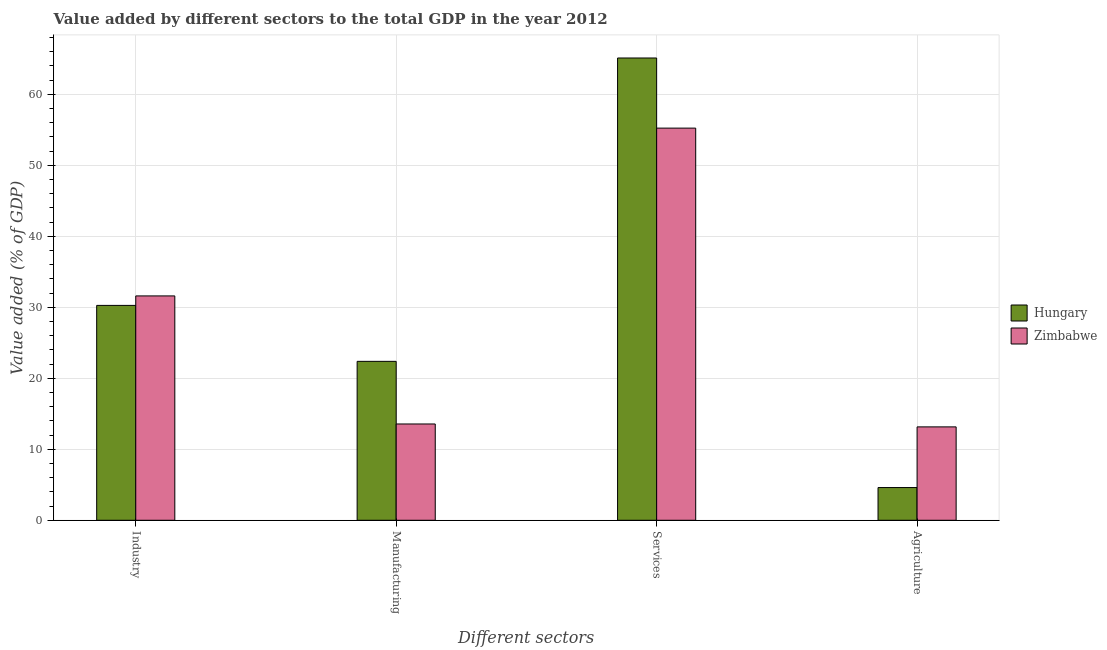How many different coloured bars are there?
Ensure brevity in your answer.  2. How many groups of bars are there?
Keep it short and to the point. 4. Are the number of bars on each tick of the X-axis equal?
Provide a short and direct response. Yes. How many bars are there on the 3rd tick from the right?
Your answer should be very brief. 2. What is the label of the 1st group of bars from the left?
Keep it short and to the point. Industry. What is the value added by services sector in Zimbabwe?
Offer a very short reply. 55.24. Across all countries, what is the maximum value added by manufacturing sector?
Provide a short and direct response. 22.39. Across all countries, what is the minimum value added by industrial sector?
Offer a terse response. 30.27. In which country was the value added by agricultural sector maximum?
Keep it short and to the point. Zimbabwe. In which country was the value added by industrial sector minimum?
Your answer should be very brief. Hungary. What is the total value added by industrial sector in the graph?
Your response must be concise. 61.87. What is the difference between the value added by industrial sector in Zimbabwe and that in Hungary?
Offer a very short reply. 1.33. What is the difference between the value added by agricultural sector in Hungary and the value added by manufacturing sector in Zimbabwe?
Provide a short and direct response. -8.96. What is the average value added by agricultural sector per country?
Provide a succinct answer. 8.88. What is the difference between the value added by agricultural sector and value added by services sector in Zimbabwe?
Keep it short and to the point. -42.09. What is the ratio of the value added by services sector in Hungary to that in Zimbabwe?
Make the answer very short. 1.18. Is the difference between the value added by services sector in Hungary and Zimbabwe greater than the difference between the value added by manufacturing sector in Hungary and Zimbabwe?
Ensure brevity in your answer.  Yes. What is the difference between the highest and the second highest value added by agricultural sector?
Make the answer very short. 8.55. What is the difference between the highest and the lowest value added by manufacturing sector?
Your answer should be very brief. 8.82. Is it the case that in every country, the sum of the value added by agricultural sector and value added by manufacturing sector is greater than the sum of value added by industrial sector and value added by services sector?
Offer a very short reply. No. What does the 2nd bar from the left in Industry represents?
Offer a very short reply. Zimbabwe. What does the 1st bar from the right in Industry represents?
Make the answer very short. Zimbabwe. Is it the case that in every country, the sum of the value added by industrial sector and value added by manufacturing sector is greater than the value added by services sector?
Ensure brevity in your answer.  No. How many bars are there?
Your answer should be compact. 8. Where does the legend appear in the graph?
Provide a succinct answer. Center right. What is the title of the graph?
Your answer should be compact. Value added by different sectors to the total GDP in the year 2012. What is the label or title of the X-axis?
Your answer should be very brief. Different sectors. What is the label or title of the Y-axis?
Make the answer very short. Value added (% of GDP). What is the Value added (% of GDP) in Hungary in Industry?
Make the answer very short. 30.27. What is the Value added (% of GDP) of Zimbabwe in Industry?
Ensure brevity in your answer.  31.6. What is the Value added (% of GDP) in Hungary in Manufacturing?
Offer a very short reply. 22.39. What is the Value added (% of GDP) of Zimbabwe in Manufacturing?
Provide a succinct answer. 13.57. What is the Value added (% of GDP) in Hungary in Services?
Keep it short and to the point. 65.12. What is the Value added (% of GDP) in Zimbabwe in Services?
Provide a succinct answer. 55.24. What is the Value added (% of GDP) in Hungary in Agriculture?
Your answer should be compact. 4.61. What is the Value added (% of GDP) of Zimbabwe in Agriculture?
Keep it short and to the point. 13.15. Across all Different sectors, what is the maximum Value added (% of GDP) of Hungary?
Ensure brevity in your answer.  65.12. Across all Different sectors, what is the maximum Value added (% of GDP) of Zimbabwe?
Ensure brevity in your answer.  55.24. Across all Different sectors, what is the minimum Value added (% of GDP) in Hungary?
Ensure brevity in your answer.  4.61. Across all Different sectors, what is the minimum Value added (% of GDP) of Zimbabwe?
Provide a succinct answer. 13.15. What is the total Value added (% of GDP) of Hungary in the graph?
Keep it short and to the point. 122.39. What is the total Value added (% of GDP) of Zimbabwe in the graph?
Make the answer very short. 113.57. What is the difference between the Value added (% of GDP) in Hungary in Industry and that in Manufacturing?
Your response must be concise. 7.88. What is the difference between the Value added (% of GDP) of Zimbabwe in Industry and that in Manufacturing?
Offer a terse response. 18.04. What is the difference between the Value added (% of GDP) in Hungary in Industry and that in Services?
Your answer should be very brief. -34.85. What is the difference between the Value added (% of GDP) of Zimbabwe in Industry and that in Services?
Provide a short and direct response. -23.64. What is the difference between the Value added (% of GDP) in Hungary in Industry and that in Agriculture?
Offer a terse response. 25.66. What is the difference between the Value added (% of GDP) of Zimbabwe in Industry and that in Agriculture?
Your response must be concise. 18.45. What is the difference between the Value added (% of GDP) in Hungary in Manufacturing and that in Services?
Your answer should be compact. -42.74. What is the difference between the Value added (% of GDP) of Zimbabwe in Manufacturing and that in Services?
Provide a short and direct response. -41.68. What is the difference between the Value added (% of GDP) of Hungary in Manufacturing and that in Agriculture?
Keep it short and to the point. 17.78. What is the difference between the Value added (% of GDP) in Zimbabwe in Manufacturing and that in Agriculture?
Make the answer very short. 0.41. What is the difference between the Value added (% of GDP) of Hungary in Services and that in Agriculture?
Offer a very short reply. 60.51. What is the difference between the Value added (% of GDP) of Zimbabwe in Services and that in Agriculture?
Your answer should be very brief. 42.09. What is the difference between the Value added (% of GDP) in Hungary in Industry and the Value added (% of GDP) in Zimbabwe in Manufacturing?
Offer a very short reply. 16.7. What is the difference between the Value added (% of GDP) in Hungary in Industry and the Value added (% of GDP) in Zimbabwe in Services?
Your answer should be very brief. -24.97. What is the difference between the Value added (% of GDP) in Hungary in Industry and the Value added (% of GDP) in Zimbabwe in Agriculture?
Offer a terse response. 17.12. What is the difference between the Value added (% of GDP) in Hungary in Manufacturing and the Value added (% of GDP) in Zimbabwe in Services?
Your answer should be compact. -32.86. What is the difference between the Value added (% of GDP) of Hungary in Manufacturing and the Value added (% of GDP) of Zimbabwe in Agriculture?
Your answer should be very brief. 9.23. What is the difference between the Value added (% of GDP) in Hungary in Services and the Value added (% of GDP) in Zimbabwe in Agriculture?
Make the answer very short. 51.97. What is the average Value added (% of GDP) of Hungary per Different sectors?
Ensure brevity in your answer.  30.6. What is the average Value added (% of GDP) of Zimbabwe per Different sectors?
Provide a succinct answer. 28.39. What is the difference between the Value added (% of GDP) of Hungary and Value added (% of GDP) of Zimbabwe in Industry?
Make the answer very short. -1.33. What is the difference between the Value added (% of GDP) of Hungary and Value added (% of GDP) of Zimbabwe in Manufacturing?
Provide a short and direct response. 8.82. What is the difference between the Value added (% of GDP) in Hungary and Value added (% of GDP) in Zimbabwe in Services?
Your answer should be very brief. 9.88. What is the difference between the Value added (% of GDP) of Hungary and Value added (% of GDP) of Zimbabwe in Agriculture?
Ensure brevity in your answer.  -8.55. What is the ratio of the Value added (% of GDP) of Hungary in Industry to that in Manufacturing?
Offer a terse response. 1.35. What is the ratio of the Value added (% of GDP) in Zimbabwe in Industry to that in Manufacturing?
Your response must be concise. 2.33. What is the ratio of the Value added (% of GDP) in Hungary in Industry to that in Services?
Offer a terse response. 0.46. What is the ratio of the Value added (% of GDP) in Zimbabwe in Industry to that in Services?
Provide a short and direct response. 0.57. What is the ratio of the Value added (% of GDP) in Hungary in Industry to that in Agriculture?
Keep it short and to the point. 6.57. What is the ratio of the Value added (% of GDP) of Zimbabwe in Industry to that in Agriculture?
Provide a succinct answer. 2.4. What is the ratio of the Value added (% of GDP) in Hungary in Manufacturing to that in Services?
Your response must be concise. 0.34. What is the ratio of the Value added (% of GDP) in Zimbabwe in Manufacturing to that in Services?
Ensure brevity in your answer.  0.25. What is the ratio of the Value added (% of GDP) in Hungary in Manufacturing to that in Agriculture?
Make the answer very short. 4.86. What is the ratio of the Value added (% of GDP) of Zimbabwe in Manufacturing to that in Agriculture?
Ensure brevity in your answer.  1.03. What is the ratio of the Value added (% of GDP) in Hungary in Services to that in Agriculture?
Offer a terse response. 14.13. What is the ratio of the Value added (% of GDP) in Zimbabwe in Services to that in Agriculture?
Offer a terse response. 4.2. What is the difference between the highest and the second highest Value added (% of GDP) of Hungary?
Provide a short and direct response. 34.85. What is the difference between the highest and the second highest Value added (% of GDP) in Zimbabwe?
Offer a terse response. 23.64. What is the difference between the highest and the lowest Value added (% of GDP) in Hungary?
Make the answer very short. 60.51. What is the difference between the highest and the lowest Value added (% of GDP) in Zimbabwe?
Offer a very short reply. 42.09. 